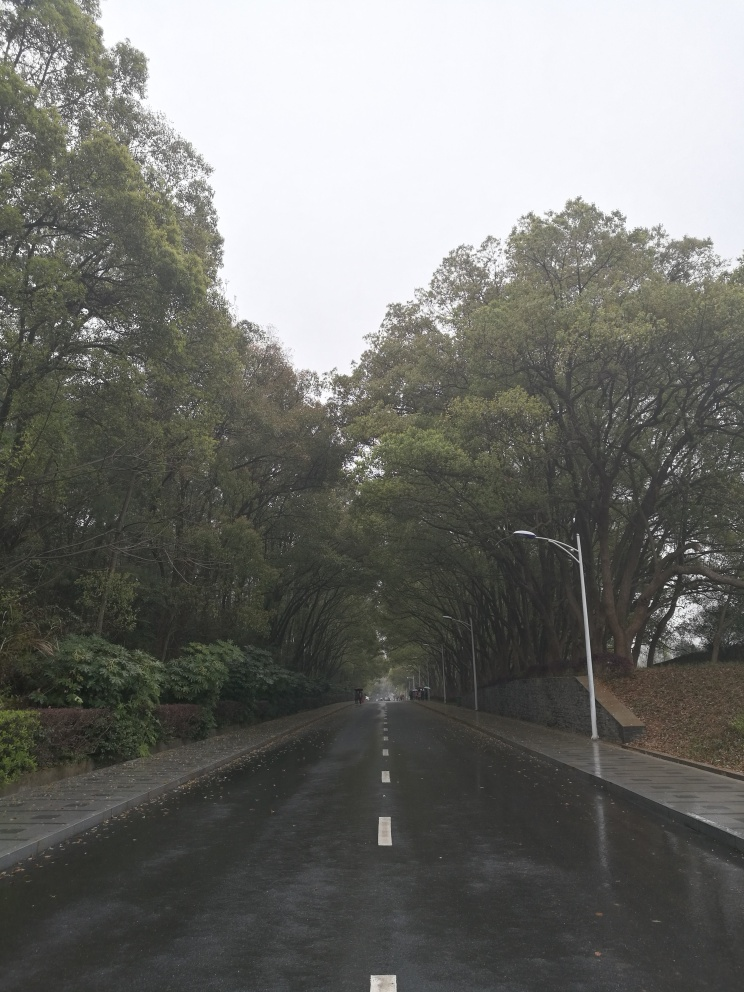What time of day does this image appear to capture, and what weather conditions are suggested? The image appears to capture a scene from the daytime, potentially in the late morning or early afternoon, given the natural light despite the overcast sky. The weather conditions suggest a cloudy or overcast day, with potential light rainfall, as evidenced by the wet road surface which reflects the muted daylight. 